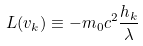Convert formula to latex. <formula><loc_0><loc_0><loc_500><loc_500>L ( v _ { k } ) \equiv - m _ { 0 } c ^ { 2 } \frac { h _ { k } } \lambda</formula> 